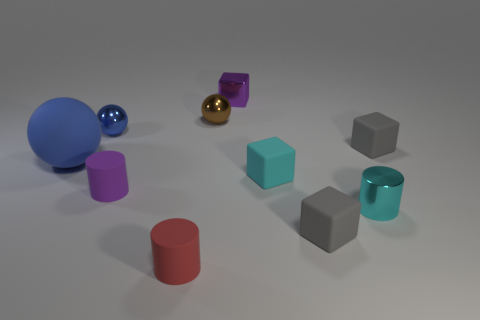Are there any tiny metal cylinders in front of the matte cylinder that is in front of the small purple rubber thing?
Ensure brevity in your answer.  No. How many cubes are either tiny red things or small brown objects?
Offer a terse response. 0. There is a gray matte cube behind the large blue matte thing that is in front of the purple thing that is on the right side of the small red object; what is its size?
Ensure brevity in your answer.  Small. There is a tiny blue shiny thing; are there any small purple matte cylinders behind it?
Keep it short and to the point. No. What is the shape of the metal object that is the same color as the matte sphere?
Your answer should be compact. Sphere. What number of objects are spheres that are to the left of the red cylinder or brown rubber spheres?
Provide a succinct answer. 2. What size is the cyan block that is made of the same material as the large ball?
Offer a terse response. Small. Do the cyan matte object and the purple object in front of the purple cube have the same size?
Offer a very short reply. Yes. There is a thing that is on the left side of the tiny brown ball and in front of the cyan shiny thing; what color is it?
Ensure brevity in your answer.  Red. What number of objects are tiny rubber objects left of the purple metal thing or tiny metal things behind the tiny blue thing?
Offer a very short reply. 4. 